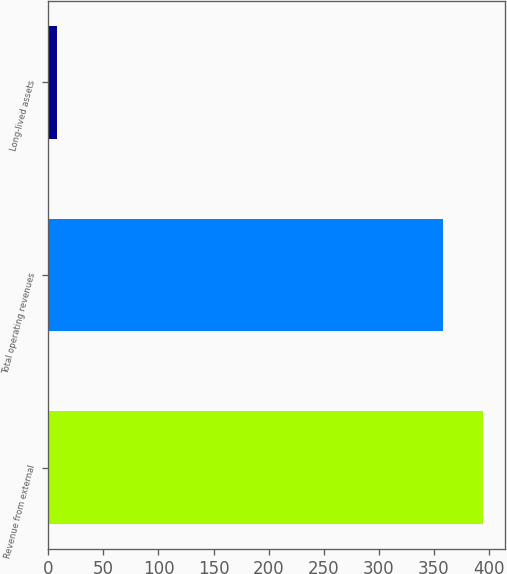<chart> <loc_0><loc_0><loc_500><loc_500><bar_chart><fcel>Revenue from external<fcel>Total operating revenues<fcel>Long-lived assets<nl><fcel>394.64<fcel>358.2<fcel>7.9<nl></chart> 